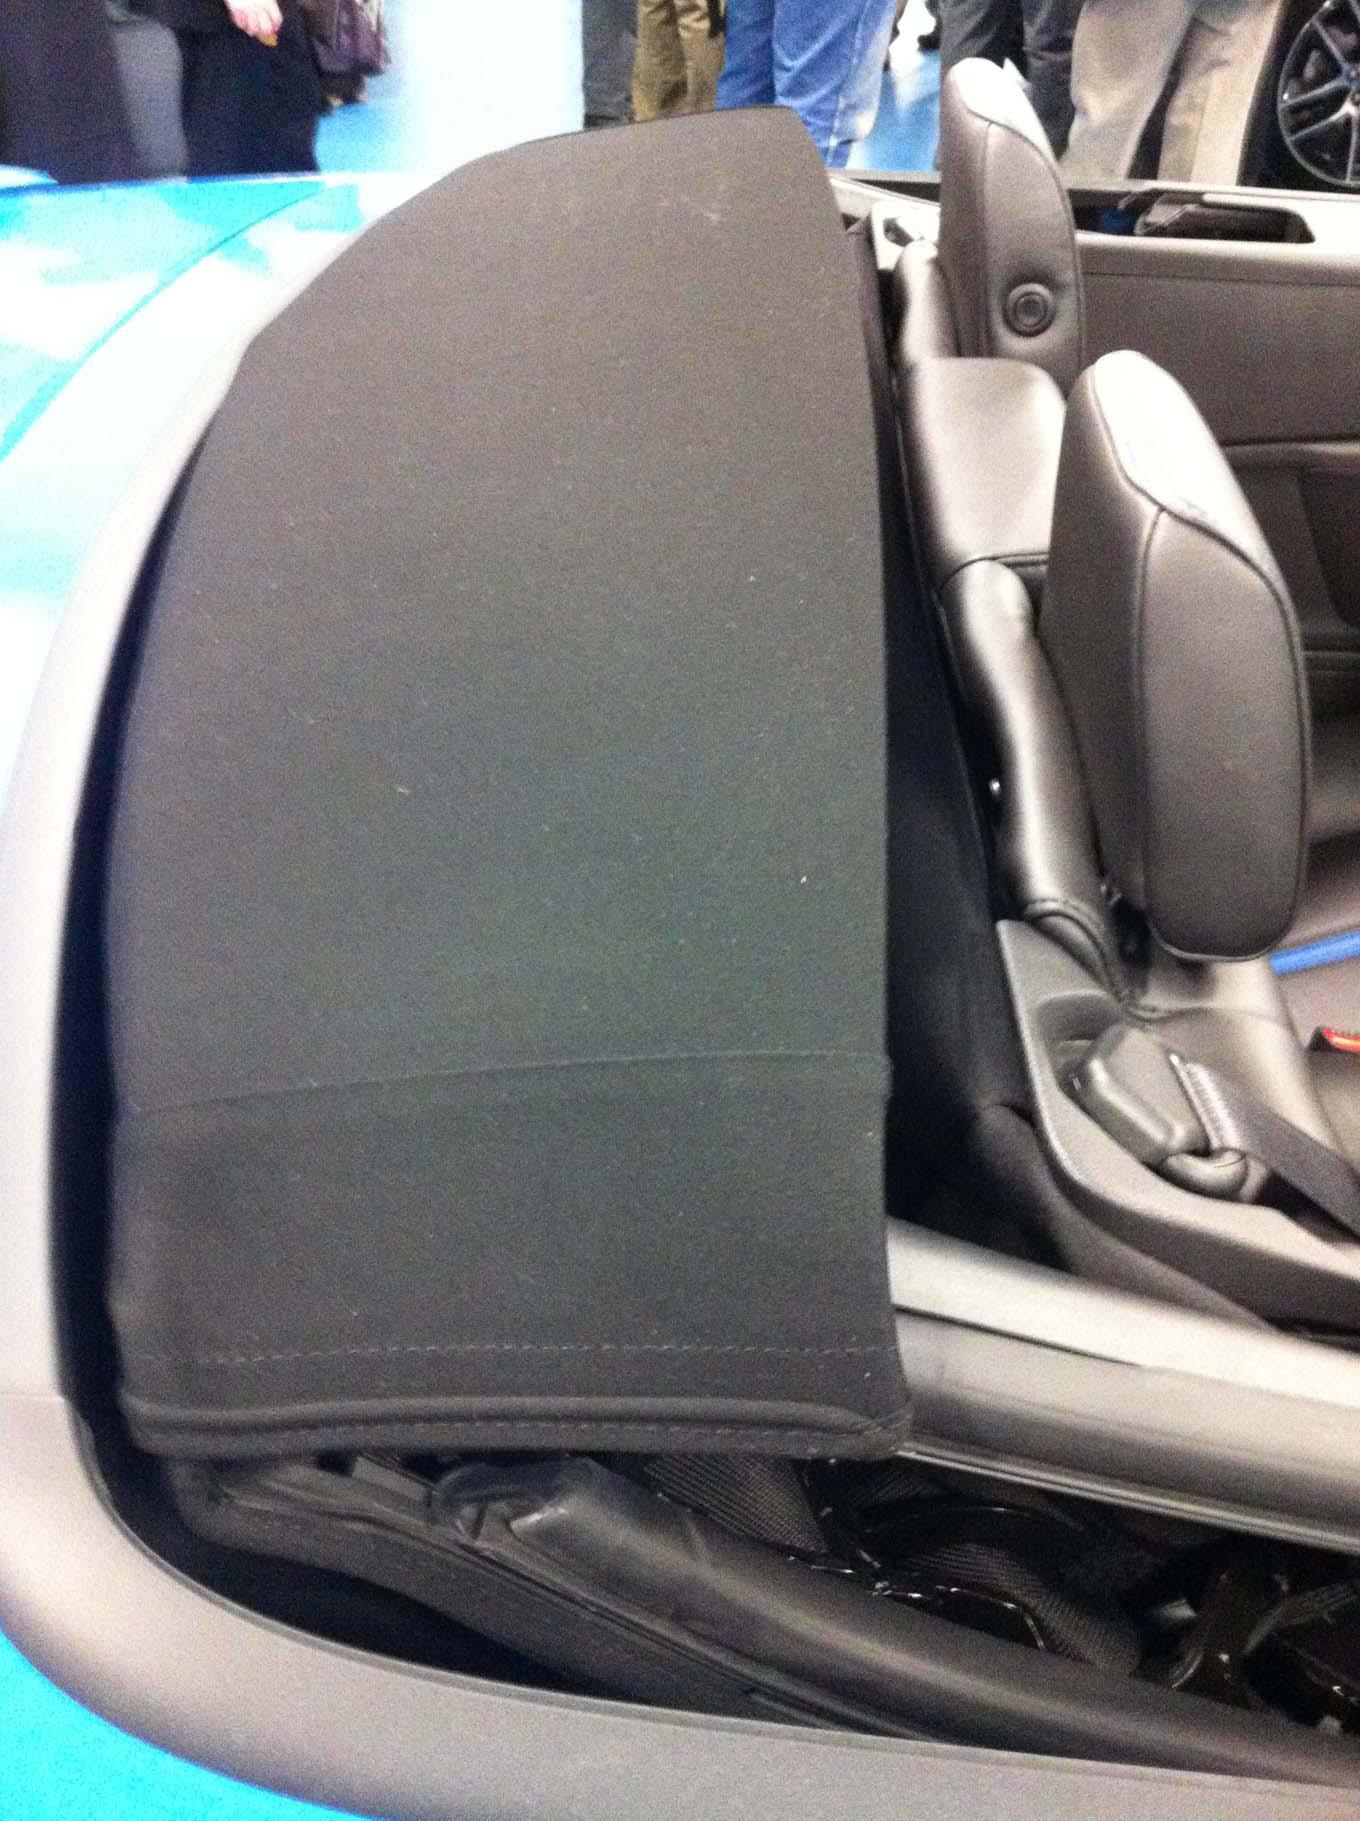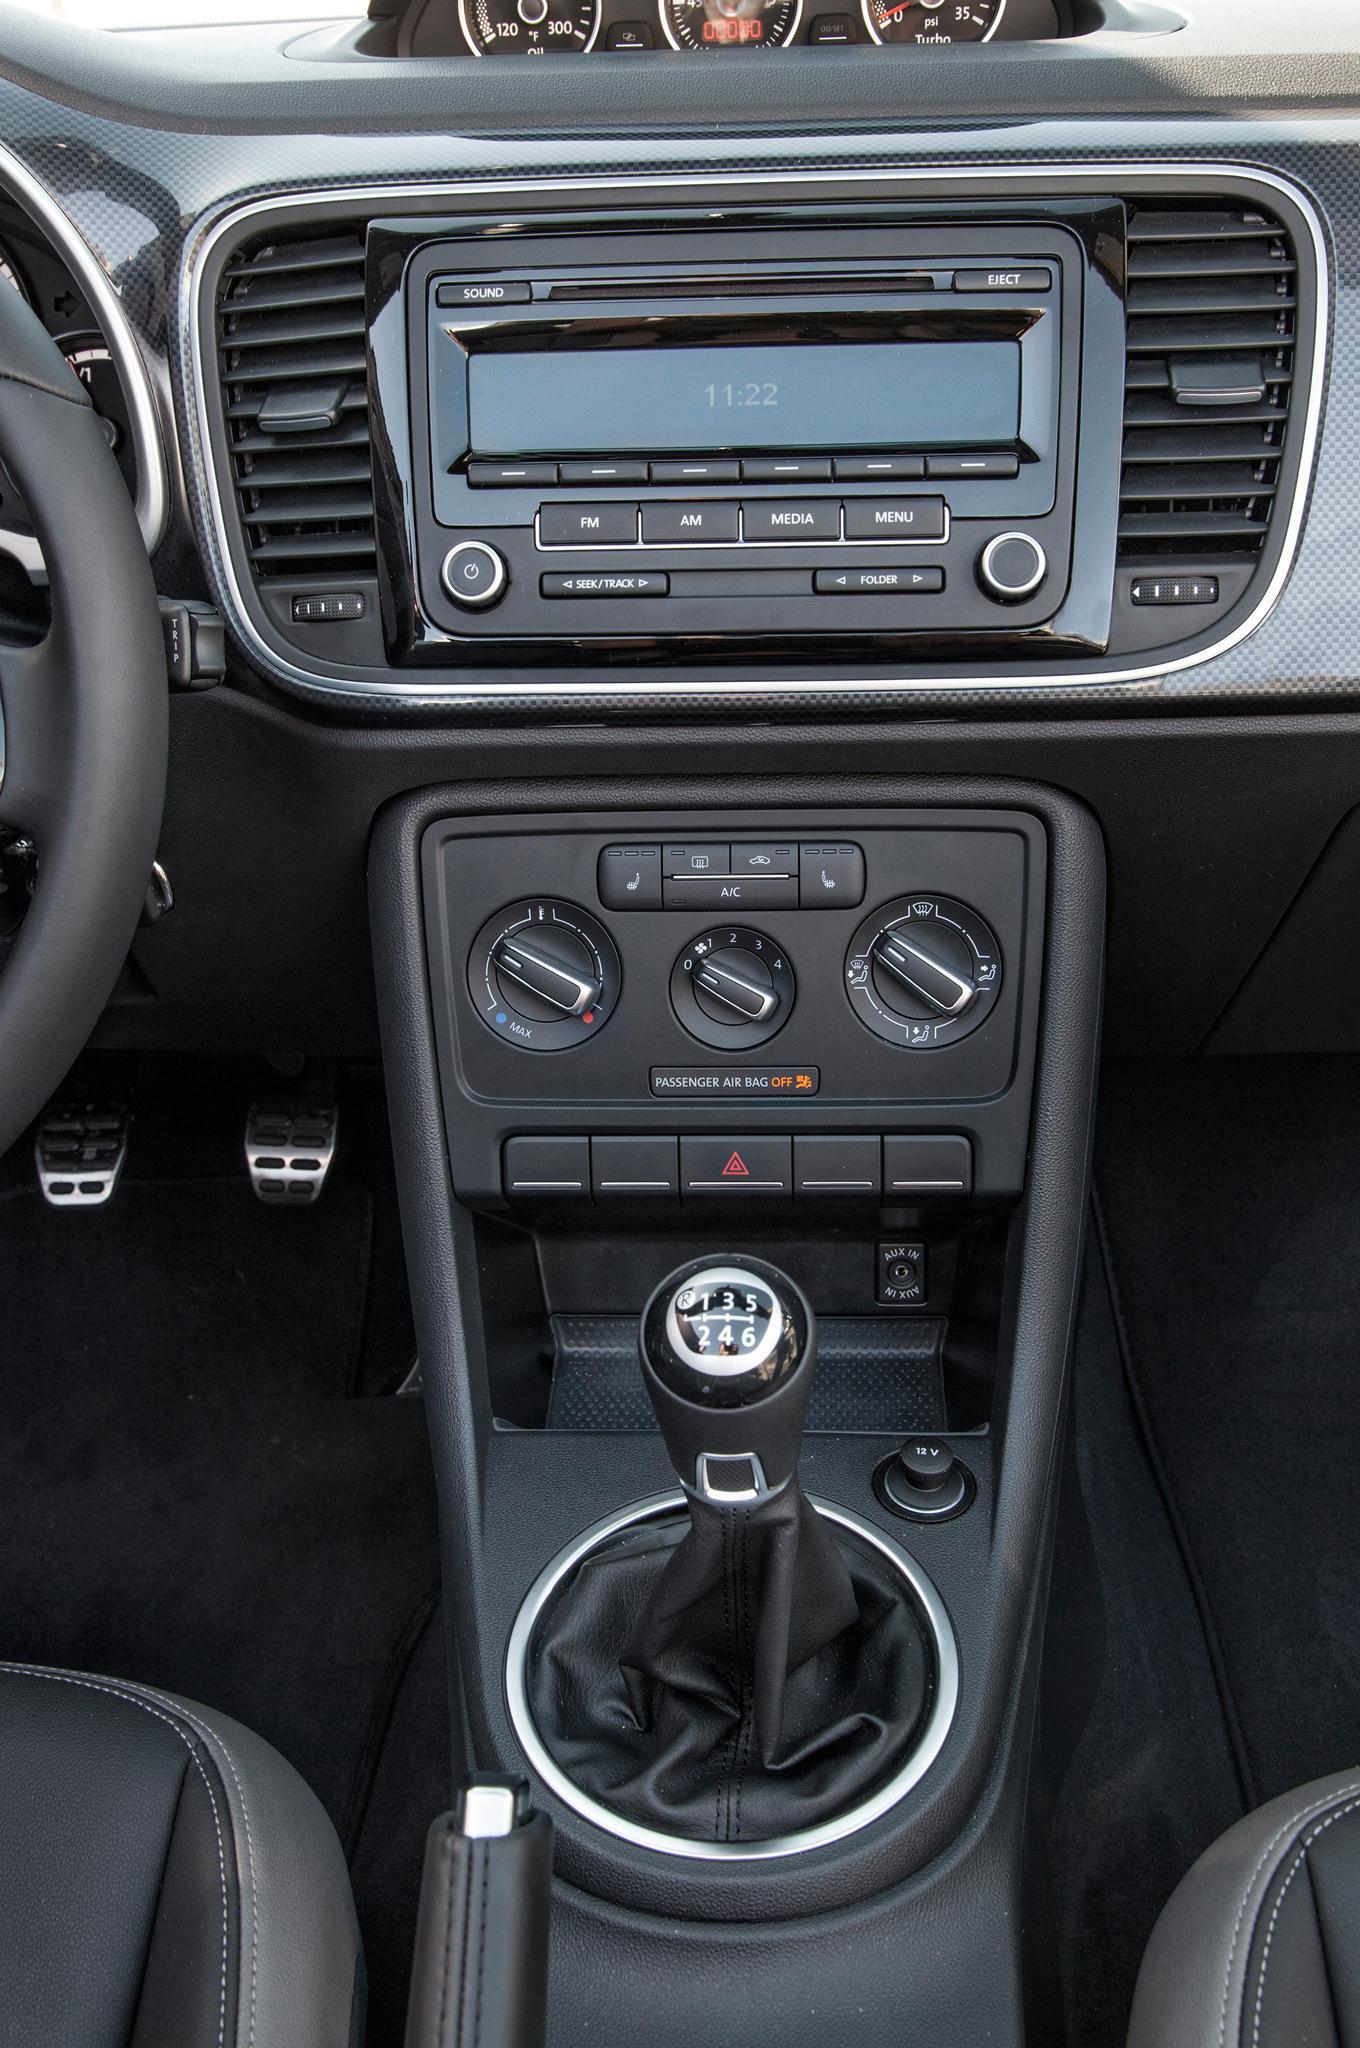The first image is the image on the left, the second image is the image on the right. Evaluate the accuracy of this statement regarding the images: "The steering wheel is visible on both cars, but the back seat is not.". Is it true? Answer yes or no. No. The first image is the image on the left, the second image is the image on the right. For the images shown, is this caption "Both car interiors show white upholstery, and no other color upholstery on the seats." true? Answer yes or no. No. 